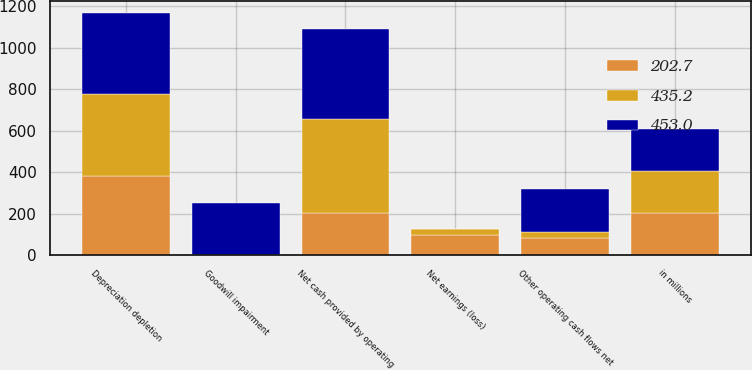Convert chart. <chart><loc_0><loc_0><loc_500><loc_500><stacked_bar_chart><ecel><fcel>in millions<fcel>Net earnings (loss)<fcel>Depreciation depletion<fcel>Goodwill impairment<fcel>Other operating cash flows net<fcel>Net cash provided by operating<nl><fcel>202.7<fcel>202.7<fcel>96.5<fcel>382.1<fcel>0<fcel>82.9<fcel>202.7<nl><fcel>435.2<fcel>202.7<fcel>30.3<fcel>394.6<fcel>0<fcel>28.1<fcel>453<nl><fcel>453<fcel>202.7<fcel>0.9<fcel>389.1<fcel>252.7<fcel>207.5<fcel>435.2<nl></chart> 